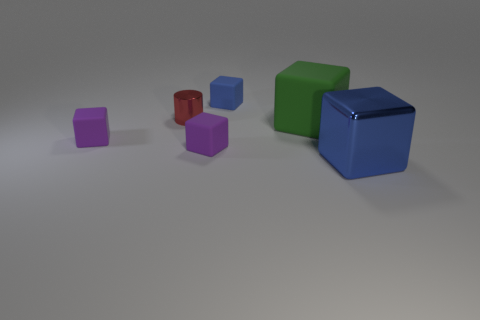What material is the cube that is the same size as the green matte thing?
Make the answer very short. Metal. What number of things are metallic objects that are to the right of the small blue thing or large gray metallic spheres?
Your response must be concise. 1. Are any tiny gray metal balls visible?
Offer a terse response. No. What is the blue thing that is behind the big blue object made of?
Give a very brief answer. Rubber. What material is the tiny thing that is the same color as the large metal cube?
Keep it short and to the point. Rubber. How many large objects are either green matte objects or purple rubber cubes?
Give a very brief answer. 1. What is the color of the tiny cylinder?
Your answer should be very brief. Red. Are there any small red metallic objects that are right of the tiny matte object that is behind the large rubber thing?
Ensure brevity in your answer.  No. Are there fewer small blue things that are to the left of the tiny red shiny cylinder than big green objects?
Offer a very short reply. Yes. Are the cube that is behind the green rubber thing and the tiny red cylinder made of the same material?
Your response must be concise. No. 